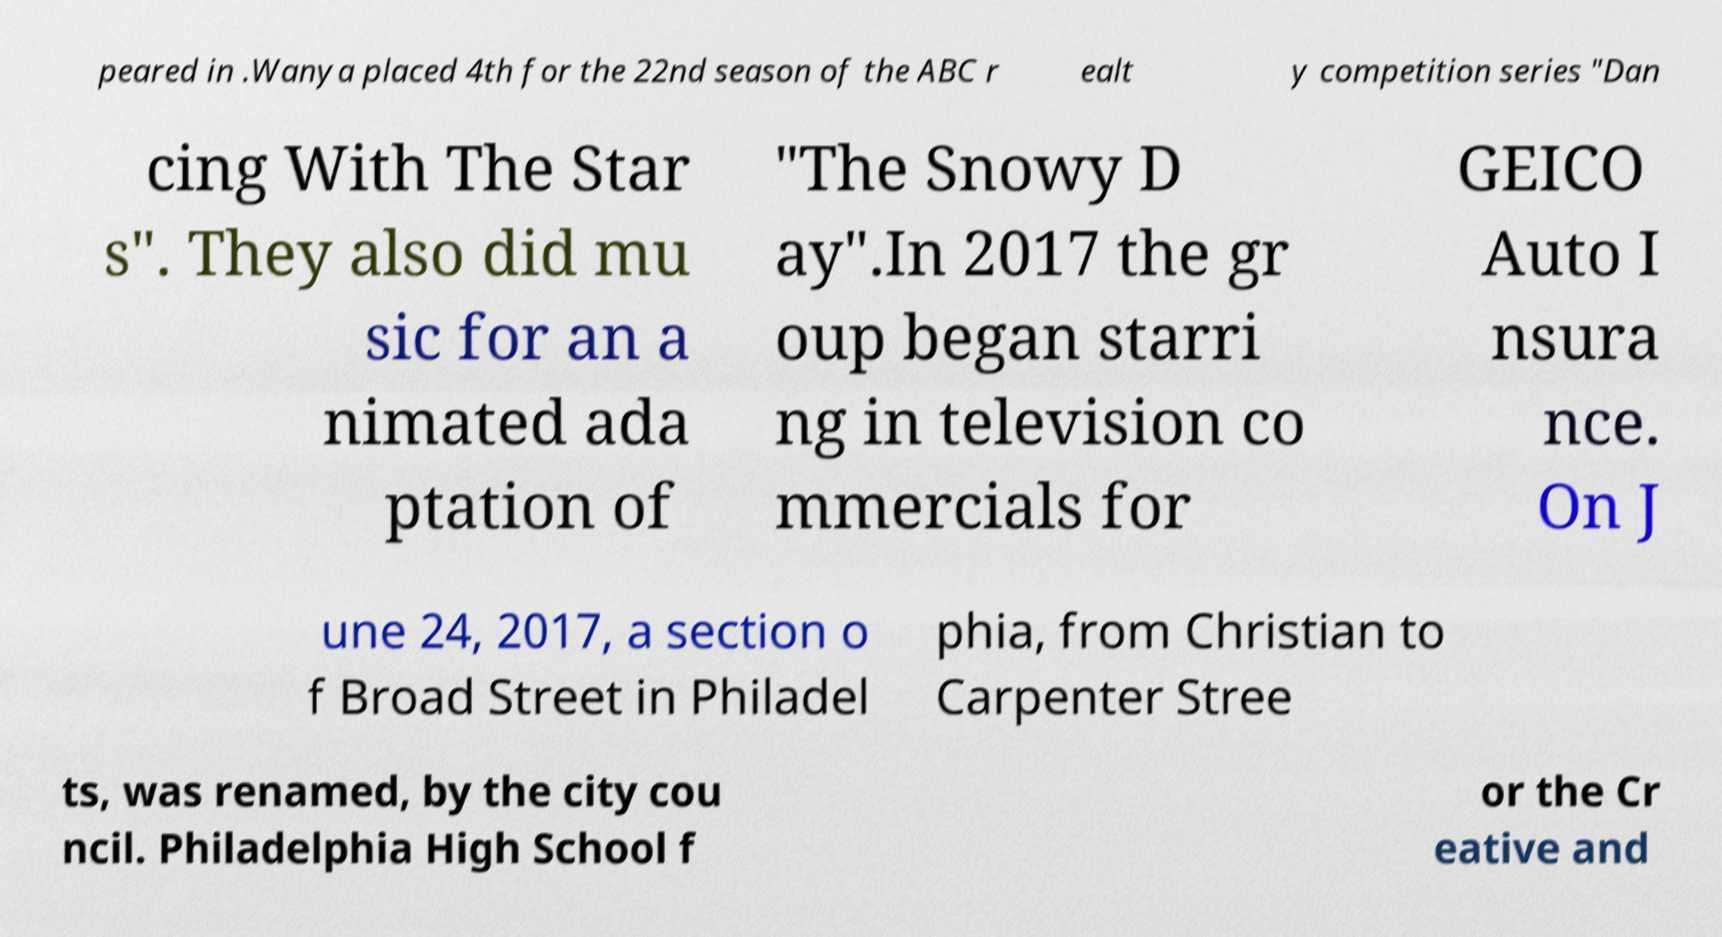Can you accurately transcribe the text from the provided image for me? peared in .Wanya placed 4th for the 22nd season of the ABC r ealt y competition series "Dan cing With The Star s". They also did mu sic for an a nimated ada ptation of "The Snowy D ay".In 2017 the gr oup began starri ng in television co mmercials for GEICO Auto I nsura nce. On J une 24, 2017, a section o f Broad Street in Philadel phia, from Christian to Carpenter Stree ts, was renamed, by the city cou ncil. Philadelphia High School f or the Cr eative and 